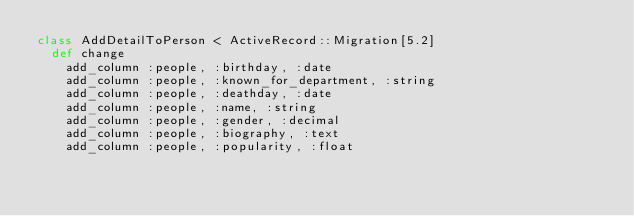<code> <loc_0><loc_0><loc_500><loc_500><_Ruby_>class AddDetailToPerson < ActiveRecord::Migration[5.2]
  def change
    add_column :people, :birthday, :date
    add_column :people, :known_for_department, :string
    add_column :people, :deathday, :date
    add_column :people, :name, :string
    add_column :people, :gender, :decimal
    add_column :people, :biography, :text
    add_column :people, :popularity, :float</code> 